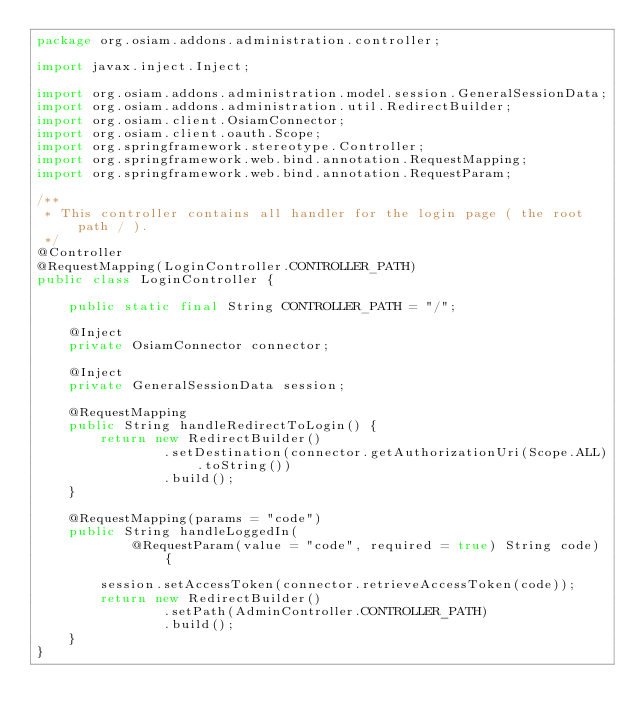Convert code to text. <code><loc_0><loc_0><loc_500><loc_500><_Java_>package org.osiam.addons.administration.controller;

import javax.inject.Inject;

import org.osiam.addons.administration.model.session.GeneralSessionData;
import org.osiam.addons.administration.util.RedirectBuilder;
import org.osiam.client.OsiamConnector;
import org.osiam.client.oauth.Scope;
import org.springframework.stereotype.Controller;
import org.springframework.web.bind.annotation.RequestMapping;
import org.springframework.web.bind.annotation.RequestParam;

/**
 * This controller contains all handler for the login page ( the root path / ).
 */
@Controller
@RequestMapping(LoginController.CONTROLLER_PATH)
public class LoginController {

    public static final String CONTROLLER_PATH = "/";

    @Inject
    private OsiamConnector connector;

    @Inject
    private GeneralSessionData session;

    @RequestMapping
    public String handleRedirectToLogin() {
        return new RedirectBuilder()
                .setDestination(connector.getAuthorizationUri(Scope.ALL).toString())
                .build();
    }

    @RequestMapping(params = "code")
    public String handleLoggedIn(
            @RequestParam(value = "code", required = true) String code) {

        session.setAccessToken(connector.retrieveAccessToken(code));
        return new RedirectBuilder()
                .setPath(AdminController.CONTROLLER_PATH)
                .build();
    }
}
</code> 